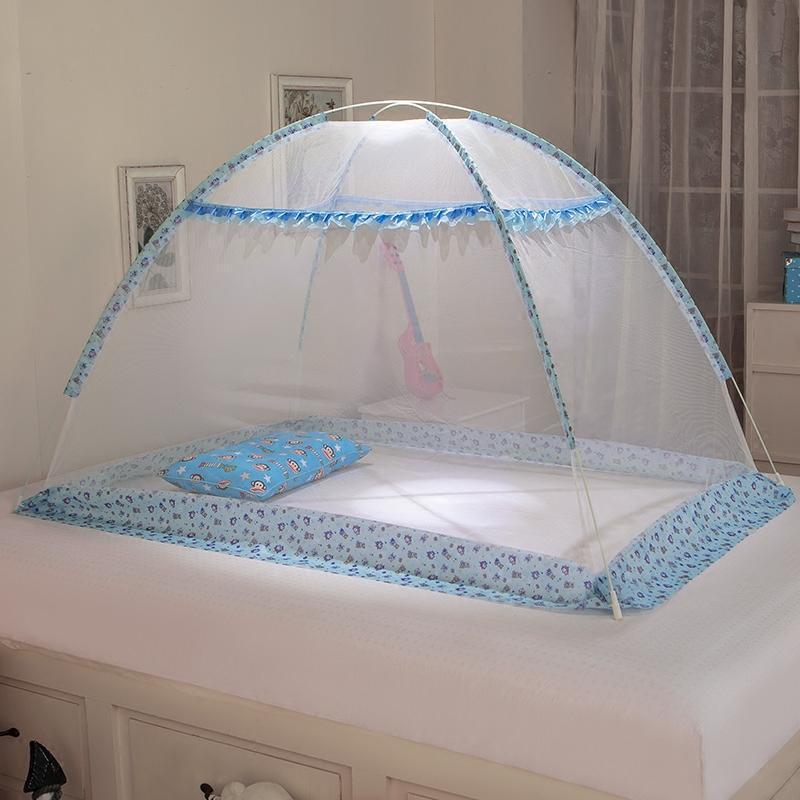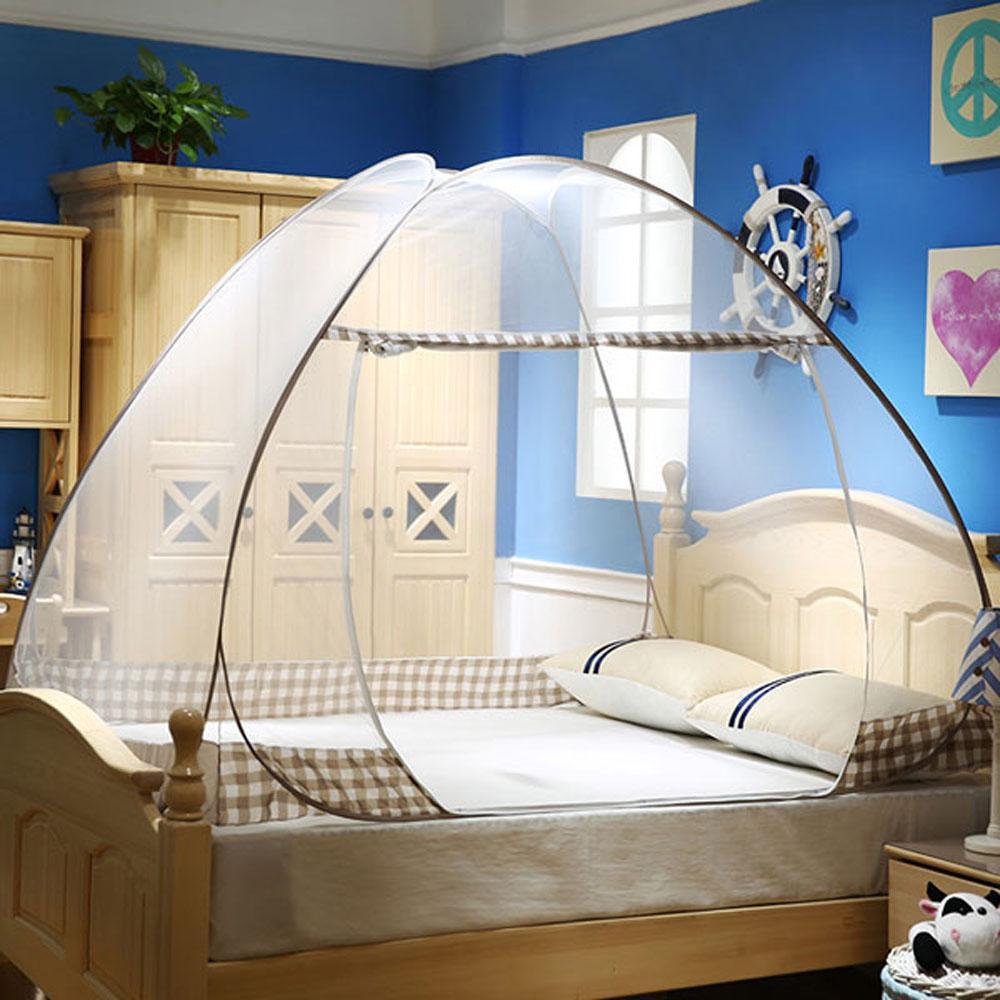The first image is the image on the left, the second image is the image on the right. Assess this claim about the two images: "A bed has a blue-trimmed canopy with a band of patterned fabric around the base.". Correct or not? Answer yes or no. Yes. 